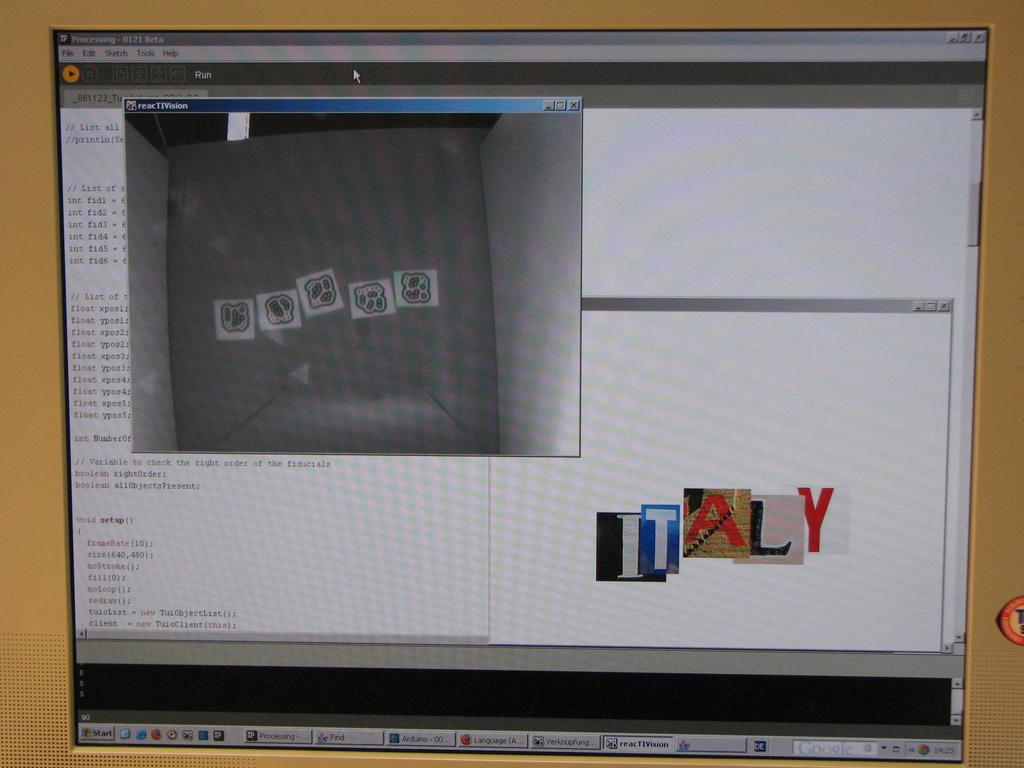<image>
Share a concise interpretation of the image provided. a computer screen with the word Italy on it in the bottom right. 